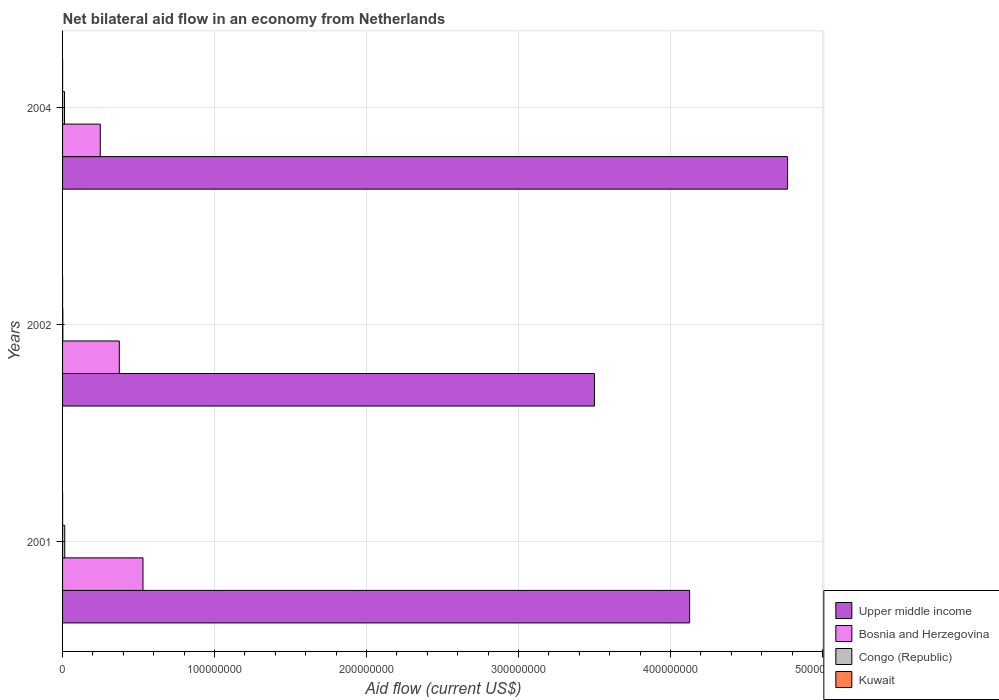Are the number of bars on each tick of the Y-axis equal?
Provide a short and direct response. Yes. How many bars are there on the 1st tick from the bottom?
Offer a terse response. 4. What is the label of the 3rd group of bars from the top?
Give a very brief answer. 2001. What is the net bilateral aid flow in Bosnia and Herzegovina in 2001?
Offer a terse response. 5.29e+07. Across all years, what is the maximum net bilateral aid flow in Bosnia and Herzegovina?
Ensure brevity in your answer.  5.29e+07. Across all years, what is the minimum net bilateral aid flow in Upper middle income?
Provide a short and direct response. 3.50e+08. In which year was the net bilateral aid flow in Bosnia and Herzegovina minimum?
Provide a succinct answer. 2004. What is the total net bilateral aid flow in Congo (Republic) in the graph?
Make the answer very short. 2.89e+06. What is the difference between the net bilateral aid flow in Kuwait in 2001 and that in 2002?
Provide a short and direct response. 10000. What is the difference between the net bilateral aid flow in Upper middle income in 2001 and the net bilateral aid flow in Bosnia and Herzegovina in 2002?
Your answer should be very brief. 3.75e+08. What is the average net bilateral aid flow in Bosnia and Herzegovina per year?
Offer a very short reply. 3.84e+07. In the year 2002, what is the difference between the net bilateral aid flow in Bosnia and Herzegovina and net bilateral aid flow in Kuwait?
Provide a succinct answer. 3.73e+07. What is the ratio of the net bilateral aid flow in Congo (Republic) in 2001 to that in 2004?
Ensure brevity in your answer.  1.12. Is the net bilateral aid flow in Upper middle income in 2001 less than that in 2002?
Provide a succinct answer. No. Is the difference between the net bilateral aid flow in Bosnia and Herzegovina in 2001 and 2004 greater than the difference between the net bilateral aid flow in Kuwait in 2001 and 2004?
Ensure brevity in your answer.  Yes. What is the difference between the highest and the second highest net bilateral aid flow in Upper middle income?
Provide a short and direct response. 6.44e+07. What is the difference between the highest and the lowest net bilateral aid flow in Upper middle income?
Your answer should be very brief. 1.27e+08. Is the sum of the net bilateral aid flow in Congo (Republic) in 2001 and 2002 greater than the maximum net bilateral aid flow in Upper middle income across all years?
Provide a succinct answer. No. What does the 4th bar from the top in 2004 represents?
Provide a short and direct response. Upper middle income. What does the 1st bar from the bottom in 2004 represents?
Offer a very short reply. Upper middle income. Is it the case that in every year, the sum of the net bilateral aid flow in Congo (Republic) and net bilateral aid flow in Kuwait is greater than the net bilateral aid flow in Bosnia and Herzegovina?
Provide a short and direct response. No. Are all the bars in the graph horizontal?
Your response must be concise. Yes. Are the values on the major ticks of X-axis written in scientific E-notation?
Make the answer very short. No. Does the graph contain grids?
Keep it short and to the point. Yes. Where does the legend appear in the graph?
Ensure brevity in your answer.  Bottom right. How are the legend labels stacked?
Offer a terse response. Vertical. What is the title of the graph?
Your answer should be compact. Net bilateral aid flow in an economy from Netherlands. What is the label or title of the X-axis?
Your answer should be compact. Aid flow (current US$). What is the label or title of the Y-axis?
Keep it short and to the point. Years. What is the Aid flow (current US$) of Upper middle income in 2001?
Your answer should be very brief. 4.13e+08. What is the Aid flow (current US$) in Bosnia and Herzegovina in 2001?
Provide a succinct answer. 5.29e+07. What is the Aid flow (current US$) in Congo (Republic) in 2001?
Your answer should be very brief. 1.43e+06. What is the Aid flow (current US$) of Kuwait in 2001?
Your answer should be very brief. 2.00e+04. What is the Aid flow (current US$) in Upper middle income in 2002?
Give a very brief answer. 3.50e+08. What is the Aid flow (current US$) of Bosnia and Herzegovina in 2002?
Your response must be concise. 3.73e+07. What is the Aid flow (current US$) in Congo (Republic) in 2002?
Ensure brevity in your answer.  1.80e+05. What is the Aid flow (current US$) of Kuwait in 2002?
Your answer should be very brief. 10000. What is the Aid flow (current US$) of Upper middle income in 2004?
Offer a terse response. 4.77e+08. What is the Aid flow (current US$) of Bosnia and Herzegovina in 2004?
Keep it short and to the point. 2.48e+07. What is the Aid flow (current US$) in Congo (Republic) in 2004?
Keep it short and to the point. 1.28e+06. What is the Aid flow (current US$) in Kuwait in 2004?
Provide a short and direct response. 2.00e+04. Across all years, what is the maximum Aid flow (current US$) of Upper middle income?
Your response must be concise. 4.77e+08. Across all years, what is the maximum Aid flow (current US$) of Bosnia and Herzegovina?
Your response must be concise. 5.29e+07. Across all years, what is the maximum Aid flow (current US$) in Congo (Republic)?
Your answer should be compact. 1.43e+06. Across all years, what is the maximum Aid flow (current US$) of Kuwait?
Keep it short and to the point. 2.00e+04. Across all years, what is the minimum Aid flow (current US$) of Upper middle income?
Ensure brevity in your answer.  3.50e+08. Across all years, what is the minimum Aid flow (current US$) in Bosnia and Herzegovina?
Make the answer very short. 2.48e+07. Across all years, what is the minimum Aid flow (current US$) of Congo (Republic)?
Your answer should be very brief. 1.80e+05. What is the total Aid flow (current US$) of Upper middle income in the graph?
Offer a very short reply. 1.24e+09. What is the total Aid flow (current US$) in Bosnia and Herzegovina in the graph?
Provide a short and direct response. 1.15e+08. What is the total Aid flow (current US$) in Congo (Republic) in the graph?
Offer a terse response. 2.89e+06. What is the difference between the Aid flow (current US$) of Upper middle income in 2001 and that in 2002?
Your answer should be compact. 6.26e+07. What is the difference between the Aid flow (current US$) in Bosnia and Herzegovina in 2001 and that in 2002?
Your answer should be very brief. 1.56e+07. What is the difference between the Aid flow (current US$) of Congo (Republic) in 2001 and that in 2002?
Give a very brief answer. 1.25e+06. What is the difference between the Aid flow (current US$) of Kuwait in 2001 and that in 2002?
Make the answer very short. 10000. What is the difference between the Aid flow (current US$) in Upper middle income in 2001 and that in 2004?
Make the answer very short. -6.44e+07. What is the difference between the Aid flow (current US$) in Bosnia and Herzegovina in 2001 and that in 2004?
Ensure brevity in your answer.  2.81e+07. What is the difference between the Aid flow (current US$) in Congo (Republic) in 2001 and that in 2004?
Offer a very short reply. 1.50e+05. What is the difference between the Aid flow (current US$) of Upper middle income in 2002 and that in 2004?
Give a very brief answer. -1.27e+08. What is the difference between the Aid flow (current US$) in Bosnia and Herzegovina in 2002 and that in 2004?
Your answer should be very brief. 1.25e+07. What is the difference between the Aid flow (current US$) of Congo (Republic) in 2002 and that in 2004?
Your answer should be compact. -1.10e+06. What is the difference between the Aid flow (current US$) in Kuwait in 2002 and that in 2004?
Make the answer very short. -10000. What is the difference between the Aid flow (current US$) in Upper middle income in 2001 and the Aid flow (current US$) in Bosnia and Herzegovina in 2002?
Keep it short and to the point. 3.75e+08. What is the difference between the Aid flow (current US$) in Upper middle income in 2001 and the Aid flow (current US$) in Congo (Republic) in 2002?
Offer a terse response. 4.12e+08. What is the difference between the Aid flow (current US$) in Upper middle income in 2001 and the Aid flow (current US$) in Kuwait in 2002?
Offer a very short reply. 4.13e+08. What is the difference between the Aid flow (current US$) of Bosnia and Herzegovina in 2001 and the Aid flow (current US$) of Congo (Republic) in 2002?
Ensure brevity in your answer.  5.27e+07. What is the difference between the Aid flow (current US$) of Bosnia and Herzegovina in 2001 and the Aid flow (current US$) of Kuwait in 2002?
Provide a succinct answer. 5.29e+07. What is the difference between the Aid flow (current US$) of Congo (Republic) in 2001 and the Aid flow (current US$) of Kuwait in 2002?
Keep it short and to the point. 1.42e+06. What is the difference between the Aid flow (current US$) in Upper middle income in 2001 and the Aid flow (current US$) in Bosnia and Herzegovina in 2004?
Your answer should be compact. 3.88e+08. What is the difference between the Aid flow (current US$) in Upper middle income in 2001 and the Aid flow (current US$) in Congo (Republic) in 2004?
Offer a terse response. 4.11e+08. What is the difference between the Aid flow (current US$) of Upper middle income in 2001 and the Aid flow (current US$) of Kuwait in 2004?
Your answer should be very brief. 4.13e+08. What is the difference between the Aid flow (current US$) of Bosnia and Herzegovina in 2001 and the Aid flow (current US$) of Congo (Republic) in 2004?
Offer a terse response. 5.16e+07. What is the difference between the Aid flow (current US$) of Bosnia and Herzegovina in 2001 and the Aid flow (current US$) of Kuwait in 2004?
Provide a succinct answer. 5.29e+07. What is the difference between the Aid flow (current US$) in Congo (Republic) in 2001 and the Aid flow (current US$) in Kuwait in 2004?
Your answer should be compact. 1.41e+06. What is the difference between the Aid flow (current US$) in Upper middle income in 2002 and the Aid flow (current US$) in Bosnia and Herzegovina in 2004?
Your response must be concise. 3.25e+08. What is the difference between the Aid flow (current US$) of Upper middle income in 2002 and the Aid flow (current US$) of Congo (Republic) in 2004?
Keep it short and to the point. 3.49e+08. What is the difference between the Aid flow (current US$) of Upper middle income in 2002 and the Aid flow (current US$) of Kuwait in 2004?
Make the answer very short. 3.50e+08. What is the difference between the Aid flow (current US$) in Bosnia and Herzegovina in 2002 and the Aid flow (current US$) in Congo (Republic) in 2004?
Provide a short and direct response. 3.61e+07. What is the difference between the Aid flow (current US$) in Bosnia and Herzegovina in 2002 and the Aid flow (current US$) in Kuwait in 2004?
Provide a short and direct response. 3.73e+07. What is the average Aid flow (current US$) in Upper middle income per year?
Offer a terse response. 4.13e+08. What is the average Aid flow (current US$) in Bosnia and Herzegovina per year?
Make the answer very short. 3.84e+07. What is the average Aid flow (current US$) of Congo (Republic) per year?
Your answer should be very brief. 9.63e+05. What is the average Aid flow (current US$) in Kuwait per year?
Offer a very short reply. 1.67e+04. In the year 2001, what is the difference between the Aid flow (current US$) in Upper middle income and Aid flow (current US$) in Bosnia and Herzegovina?
Make the answer very short. 3.60e+08. In the year 2001, what is the difference between the Aid flow (current US$) of Upper middle income and Aid flow (current US$) of Congo (Republic)?
Keep it short and to the point. 4.11e+08. In the year 2001, what is the difference between the Aid flow (current US$) of Upper middle income and Aid flow (current US$) of Kuwait?
Your answer should be very brief. 4.13e+08. In the year 2001, what is the difference between the Aid flow (current US$) in Bosnia and Herzegovina and Aid flow (current US$) in Congo (Republic)?
Your answer should be very brief. 5.15e+07. In the year 2001, what is the difference between the Aid flow (current US$) in Bosnia and Herzegovina and Aid flow (current US$) in Kuwait?
Provide a short and direct response. 5.29e+07. In the year 2001, what is the difference between the Aid flow (current US$) of Congo (Republic) and Aid flow (current US$) of Kuwait?
Offer a very short reply. 1.41e+06. In the year 2002, what is the difference between the Aid flow (current US$) of Upper middle income and Aid flow (current US$) of Bosnia and Herzegovina?
Your answer should be compact. 3.13e+08. In the year 2002, what is the difference between the Aid flow (current US$) in Upper middle income and Aid flow (current US$) in Congo (Republic)?
Your answer should be very brief. 3.50e+08. In the year 2002, what is the difference between the Aid flow (current US$) of Upper middle income and Aid flow (current US$) of Kuwait?
Ensure brevity in your answer.  3.50e+08. In the year 2002, what is the difference between the Aid flow (current US$) in Bosnia and Herzegovina and Aid flow (current US$) in Congo (Republic)?
Ensure brevity in your answer.  3.72e+07. In the year 2002, what is the difference between the Aid flow (current US$) of Bosnia and Herzegovina and Aid flow (current US$) of Kuwait?
Ensure brevity in your answer.  3.73e+07. In the year 2002, what is the difference between the Aid flow (current US$) in Congo (Republic) and Aid flow (current US$) in Kuwait?
Your answer should be very brief. 1.70e+05. In the year 2004, what is the difference between the Aid flow (current US$) in Upper middle income and Aid flow (current US$) in Bosnia and Herzegovina?
Provide a short and direct response. 4.52e+08. In the year 2004, what is the difference between the Aid flow (current US$) of Upper middle income and Aid flow (current US$) of Congo (Republic)?
Make the answer very short. 4.76e+08. In the year 2004, what is the difference between the Aid flow (current US$) in Upper middle income and Aid flow (current US$) in Kuwait?
Provide a short and direct response. 4.77e+08. In the year 2004, what is the difference between the Aid flow (current US$) of Bosnia and Herzegovina and Aid flow (current US$) of Congo (Republic)?
Your answer should be very brief. 2.35e+07. In the year 2004, what is the difference between the Aid flow (current US$) in Bosnia and Herzegovina and Aid flow (current US$) in Kuwait?
Provide a succinct answer. 2.48e+07. In the year 2004, what is the difference between the Aid flow (current US$) of Congo (Republic) and Aid flow (current US$) of Kuwait?
Your answer should be very brief. 1.26e+06. What is the ratio of the Aid flow (current US$) in Upper middle income in 2001 to that in 2002?
Your answer should be very brief. 1.18. What is the ratio of the Aid flow (current US$) of Bosnia and Herzegovina in 2001 to that in 2002?
Your response must be concise. 1.42. What is the ratio of the Aid flow (current US$) of Congo (Republic) in 2001 to that in 2002?
Offer a very short reply. 7.94. What is the ratio of the Aid flow (current US$) of Kuwait in 2001 to that in 2002?
Offer a very short reply. 2. What is the ratio of the Aid flow (current US$) of Upper middle income in 2001 to that in 2004?
Your response must be concise. 0.86. What is the ratio of the Aid flow (current US$) in Bosnia and Herzegovina in 2001 to that in 2004?
Offer a very short reply. 2.13. What is the ratio of the Aid flow (current US$) in Congo (Republic) in 2001 to that in 2004?
Give a very brief answer. 1.12. What is the ratio of the Aid flow (current US$) of Kuwait in 2001 to that in 2004?
Your answer should be compact. 1. What is the ratio of the Aid flow (current US$) in Upper middle income in 2002 to that in 2004?
Provide a succinct answer. 0.73. What is the ratio of the Aid flow (current US$) in Bosnia and Herzegovina in 2002 to that in 2004?
Keep it short and to the point. 1.5. What is the ratio of the Aid flow (current US$) in Congo (Republic) in 2002 to that in 2004?
Offer a terse response. 0.14. What is the ratio of the Aid flow (current US$) in Kuwait in 2002 to that in 2004?
Make the answer very short. 0.5. What is the difference between the highest and the second highest Aid flow (current US$) of Upper middle income?
Offer a terse response. 6.44e+07. What is the difference between the highest and the second highest Aid flow (current US$) in Bosnia and Herzegovina?
Keep it short and to the point. 1.56e+07. What is the difference between the highest and the second highest Aid flow (current US$) of Kuwait?
Provide a short and direct response. 0. What is the difference between the highest and the lowest Aid flow (current US$) of Upper middle income?
Offer a very short reply. 1.27e+08. What is the difference between the highest and the lowest Aid flow (current US$) of Bosnia and Herzegovina?
Keep it short and to the point. 2.81e+07. What is the difference between the highest and the lowest Aid flow (current US$) in Congo (Republic)?
Your answer should be compact. 1.25e+06. 